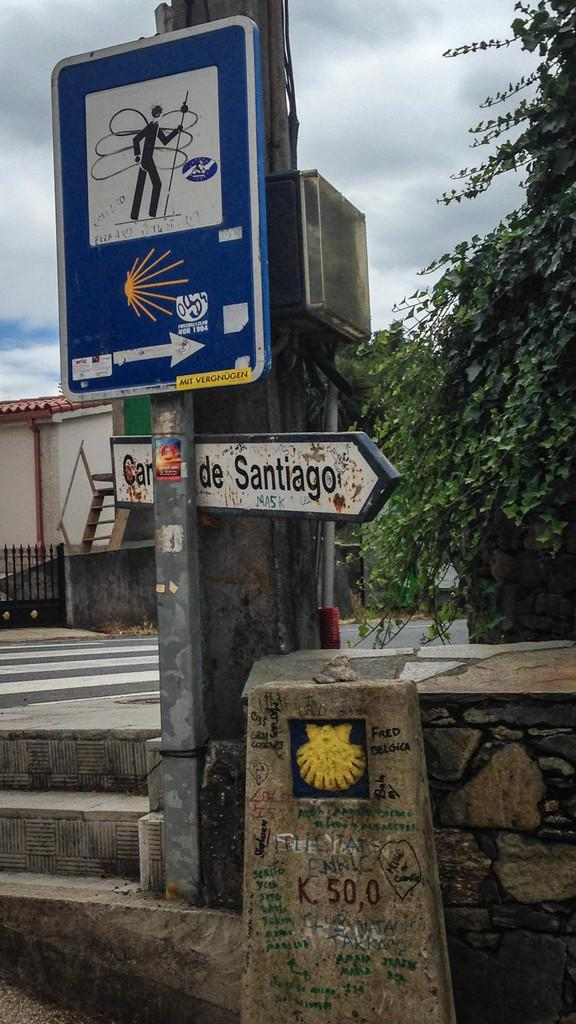What can be found in the image that contains written information? There is text in the image. What type of visual elements are present in the image that provide information or direction? There are signs in the image. Are there any numerical values or symbols present in the image? Yes, there are numbers in the image. Can you describe the person depicted in the image? There is an image of a person in the image. What type of structures can be seen in the image? There are boards in the image. What type of natural elements can be seen in the image? There are leaves in the image. What type of building is visible in the image? There is a house in the image. What type of objects can be seen in the image? There are objects in the image. What is visible in the background of the image? The sky is visible in the image. Can you describe the weather condition based on the sky in the image? The sky is cloudy in the image. What type of pail is used to collect ideas in the image? There is no pail or mention of collecting ideas present in the image. What is the title of the book held by the person in the image? There is no book or title mentioned in the image. 